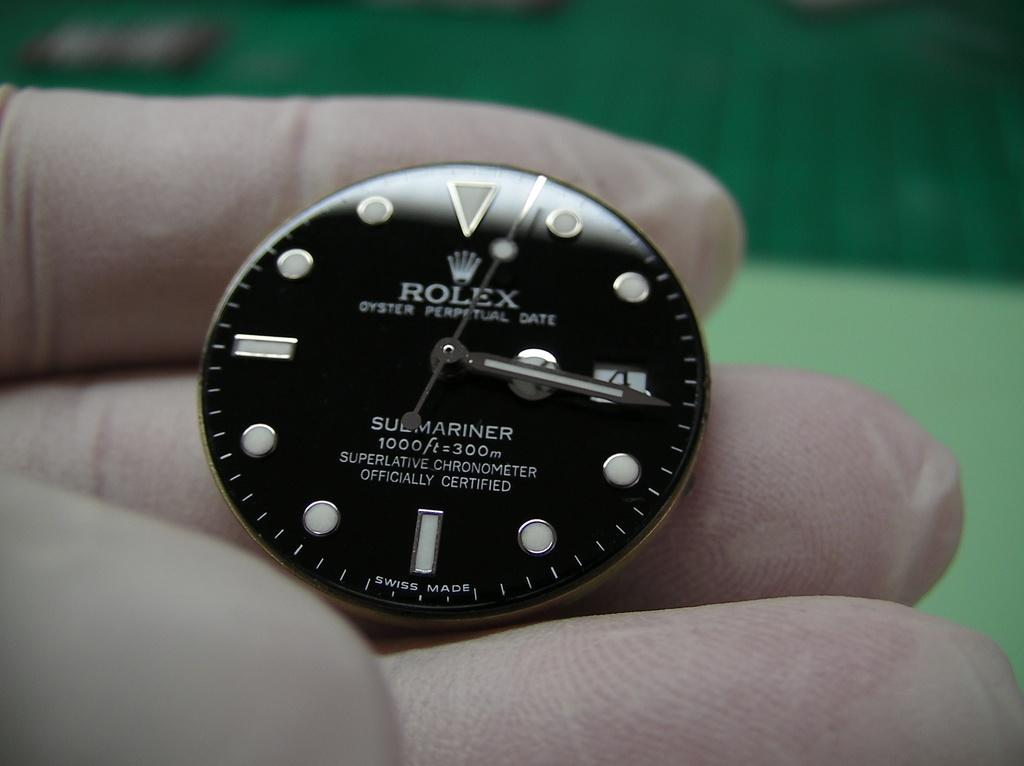<image>
Relay a brief, clear account of the picture shown. A new modern style black watch by Rolex 